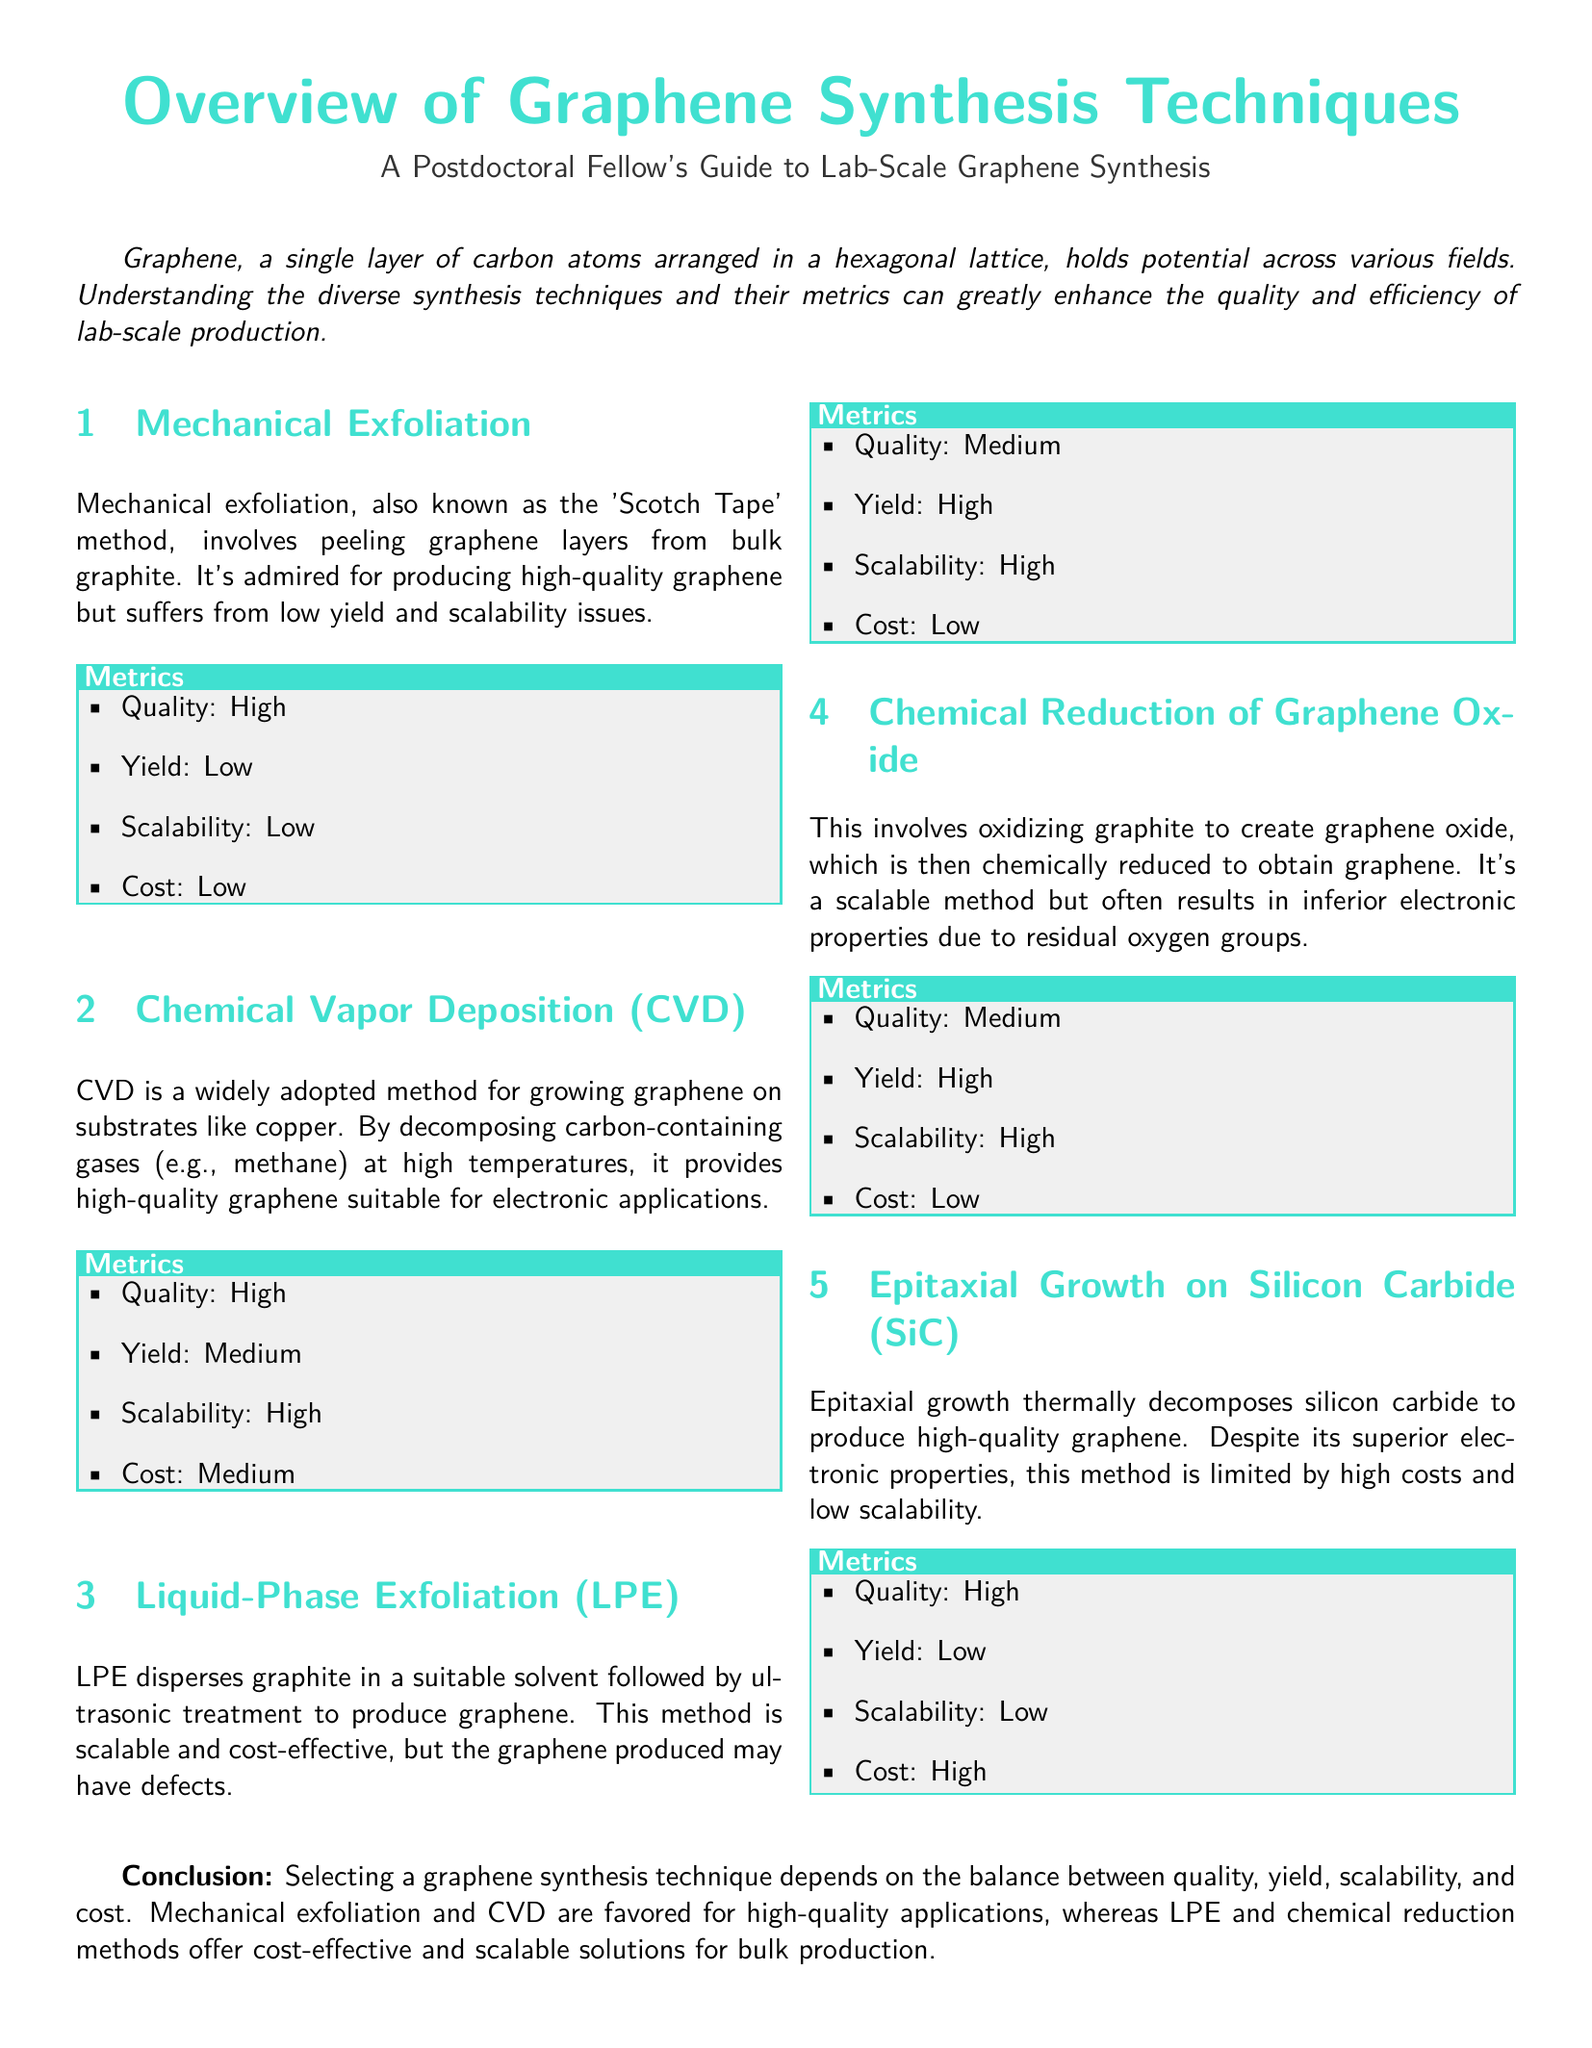What is the method known as the 'Scotch Tape' method? The 'Scotch Tape' method is a term used for mechanical exfoliation, which involves peeling graphene layers from bulk graphite.
Answer: Mechanical Exfoliation What is the quality level of Chemical Vapor Deposition (CVD) graphene? The quality level of CVD graphene is specified in the metrics section under CVD.
Answer: High Which synthesis technique has low yield and high cost? The synthesis technique with these characteristics can be found in the Epitaxial Growth on Silicon Carbide section.
Answer: Epitaxial Growth on Silicon Carbide What is the quality of graphene produced by Liquid-Phase Exfoliation (LPE)? The quality of graphene from LPE is indicated in the metrics section for this synthesis technique.
Answer: Medium Which synthesis technique offers high scalability but produces medium quality graphene? The metrics for this synthesis technique can be found in the Chemical Reduction of Graphene Oxide section.
Answer: Chemical Reduction of Graphene Oxide What is the primary advantage of Chemical Vapor Deposition (CVD) over Mechanical Exfoliation? The primary advantage can be determined from the scalability and yield metrics relative to quality.
Answer: Scalability Which technique is characterized by high yield and low cost? This information can be found in the Liquid-Phase Exfoliation section.
Answer: Liquid-Phase Exfoliation What common feature do Mechanical Exfoliation and Epitaxial Growth on Silicon Carbide share? The common feature can be discerned from their respective metrics related to yield and scalability.
Answer: Low Scalability What is mentioned as a key consideration for selecting a graphene synthesis technique? The conclusion section summarizes the factors to consider when choosing a technique.
Answer: Balance between quality, yield, scalability, and cost 